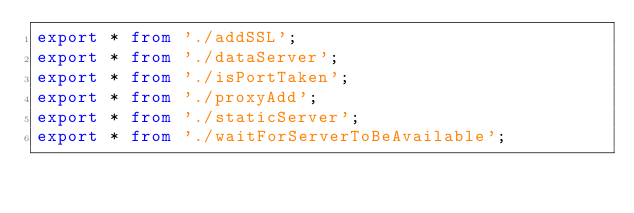Convert code to text. <code><loc_0><loc_0><loc_500><loc_500><_TypeScript_>export * from './addSSL';
export * from './dataServer';
export * from './isPortTaken';
export * from './proxyAdd';
export * from './staticServer';
export * from './waitForServerToBeAvailable';
</code> 